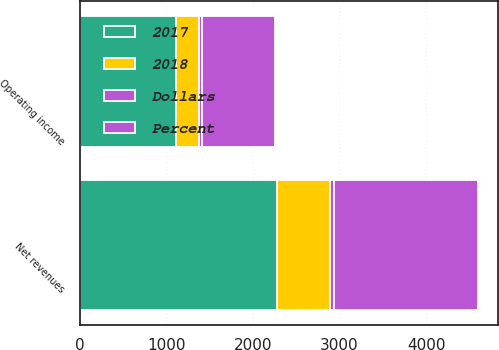<chart> <loc_0><loc_0><loc_500><loc_500><stacked_bar_chart><ecel><fcel>Net revenues<fcel>Operating income<nl><fcel>2017<fcel>2280<fcel>1111<nl><fcel>Percent<fcel>1664<fcel>839<nl><fcel>2018<fcel>616<fcel>272<nl><fcel>Dollars<fcel>37<fcel>32<nl></chart> 